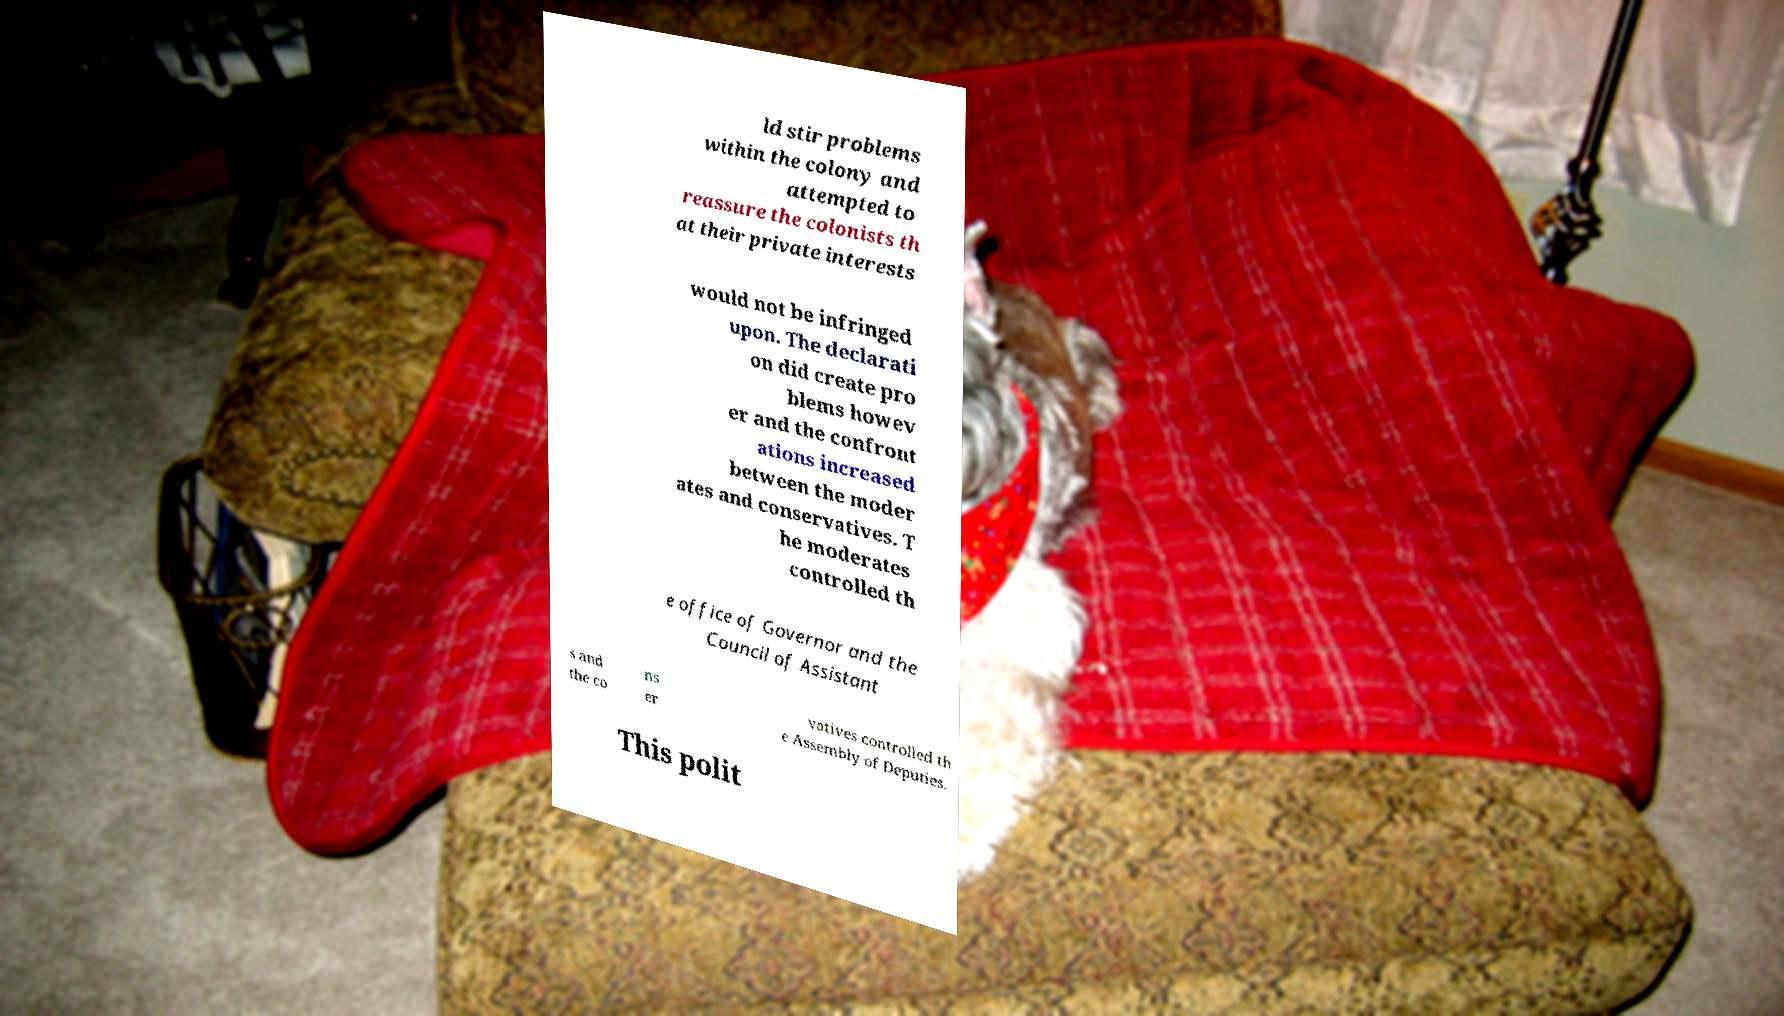Could you extract and type out the text from this image? ld stir problems within the colony and attempted to reassure the colonists th at their private interests would not be infringed upon. The declarati on did create pro blems howev er and the confront ations increased between the moder ates and conservatives. T he moderates controlled th e office of Governor and the Council of Assistant s and the co ns er vatives controlled th e Assembly of Deputies. This polit 